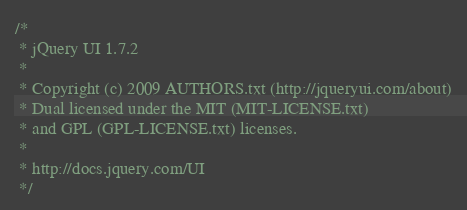<code> <loc_0><loc_0><loc_500><loc_500><_JavaScript_>/*
 * jQuery UI 1.7.2
 *
 * Copyright (c) 2009 AUTHORS.txt (http://jqueryui.com/about)
 * Dual licensed under the MIT (MIT-LICENSE.txt)
 * and GPL (GPL-LICENSE.txt) licenses.
 *
 * http://docs.jquery.com/UI
 */</code> 